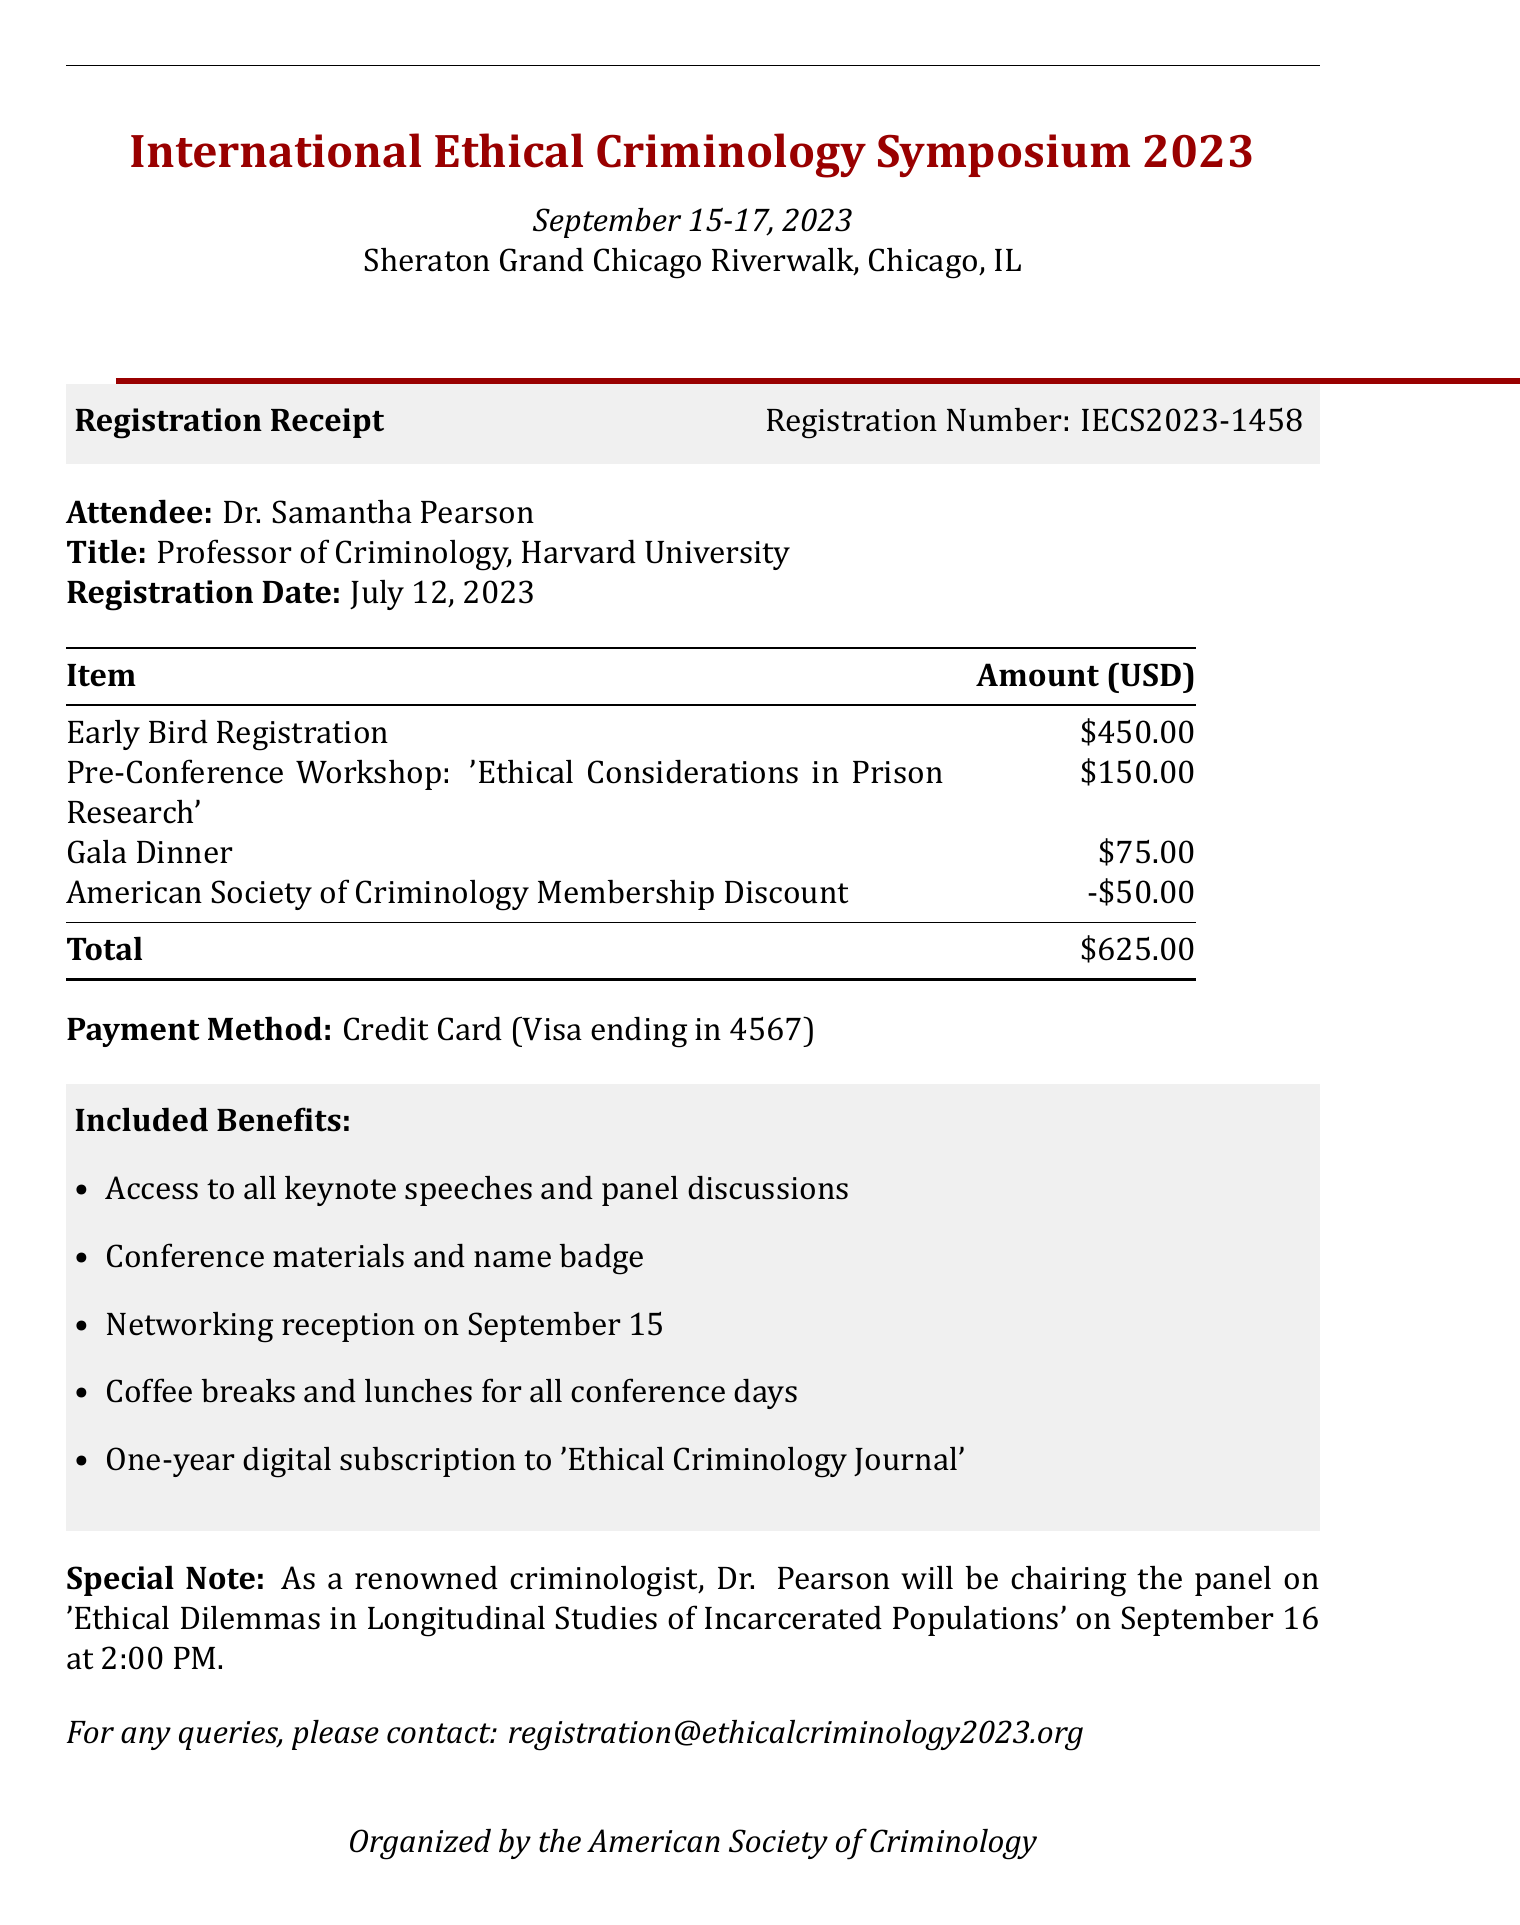What is the event name? The event name is clearly stated at the top of the document.
Answer: International Ethical Criminology Symposium 2023 What is the registration number? The registration number is provided in the registration receipt section of the document.
Answer: IECS2023-1458 What is the total amount for registration? The total amount is calculated from the fee breakdown and is highlighted in the document.
Answer: $625.00 Who is the attendee? The attendee's name is mentioned at the beginning of the receipt.
Answer: Dr. Samantha Pearson What date will the panel chaired by Dr. Pearson take place? The date is mentioned in the special note section related to Dr. Pearson's involvement.
Answer: September 16 How much does the Pre-Conference Workshop cost? The cost is specified in the fee breakdown table.
Answer: $150.00 What is the payment method used? The payment method is indicated in the payment section of the document.
Answer: Credit Card (Visa ending in 4567) What discount was applied to the registration fee? The discount is noted in the fee breakdown.
Answer: American Society of Criminology Membership Discount What are participants entitled to receive as included benefits? The included benefits are listed under a distinct section in the document.
Answer: Access to all keynote speeches and panel discussions 